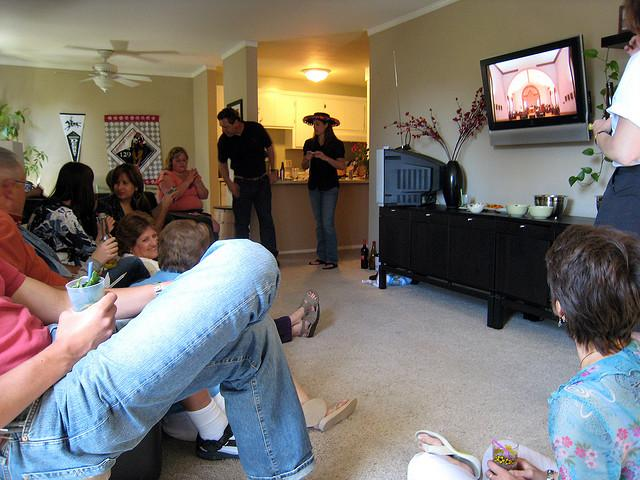What are the people looking at in the room? Please explain your reasoning. television. Everyone in the room is watching a show on tv. 